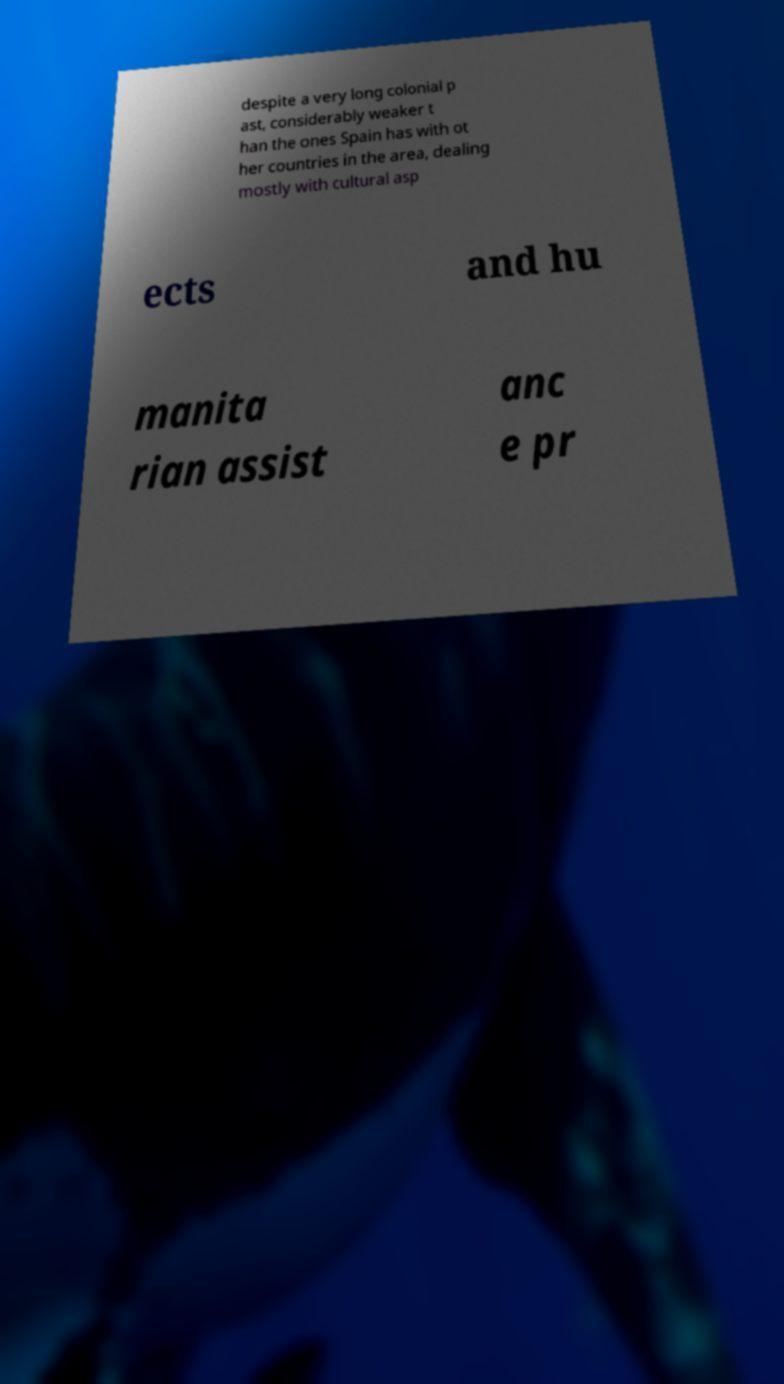I need the written content from this picture converted into text. Can you do that? despite a very long colonial p ast, considerably weaker t han the ones Spain has with ot her countries in the area, dealing mostly with cultural asp ects and hu manita rian assist anc e pr 